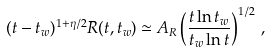Convert formula to latex. <formula><loc_0><loc_0><loc_500><loc_500>( t - t _ { w } ) ^ { 1 + \eta / 2 } R ( t , t _ { w } ) \simeq A _ { R } \left ( \frac { t \ln t _ { w } } { t _ { w } \ln t } \right ) ^ { 1 / 2 } \, ,</formula> 